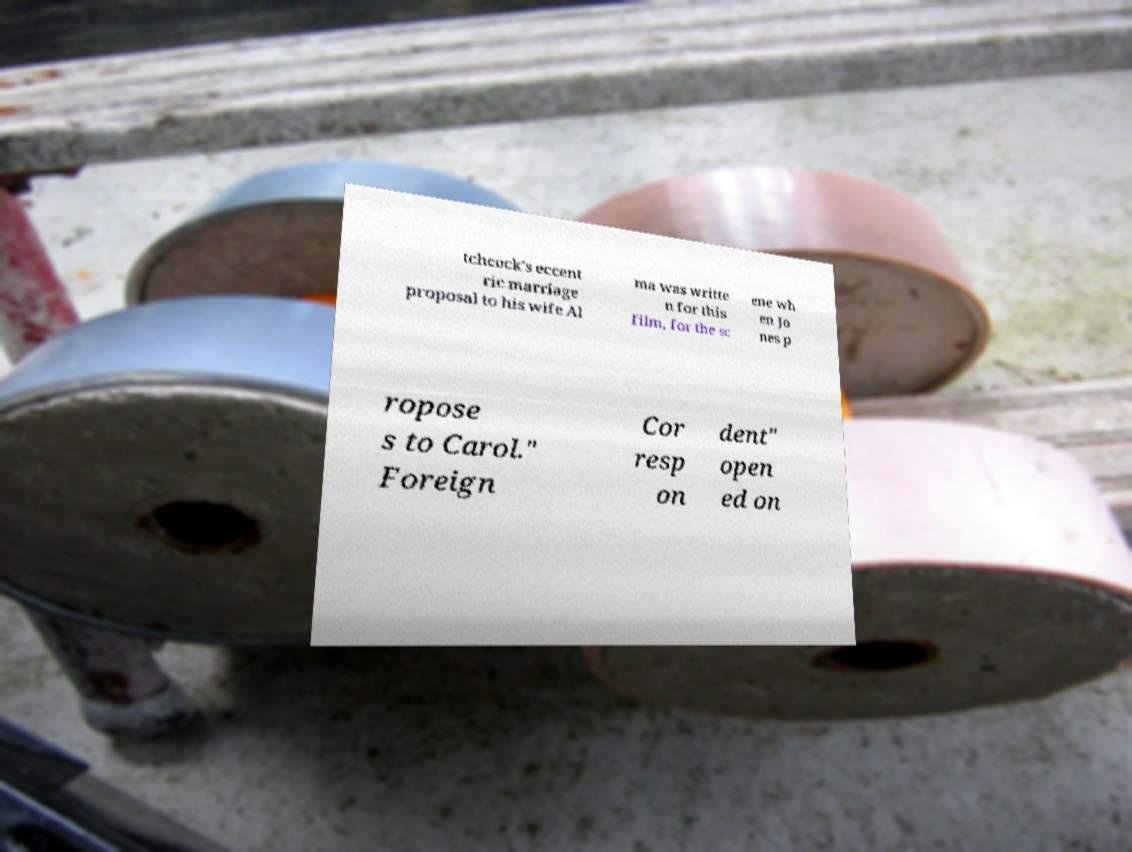Please identify and transcribe the text found in this image. tchcock's eccent ric marriage proposal to his wife Al ma was writte n for this film, for the sc ene wh en Jo nes p ropose s to Carol." Foreign Cor resp on dent" open ed on 